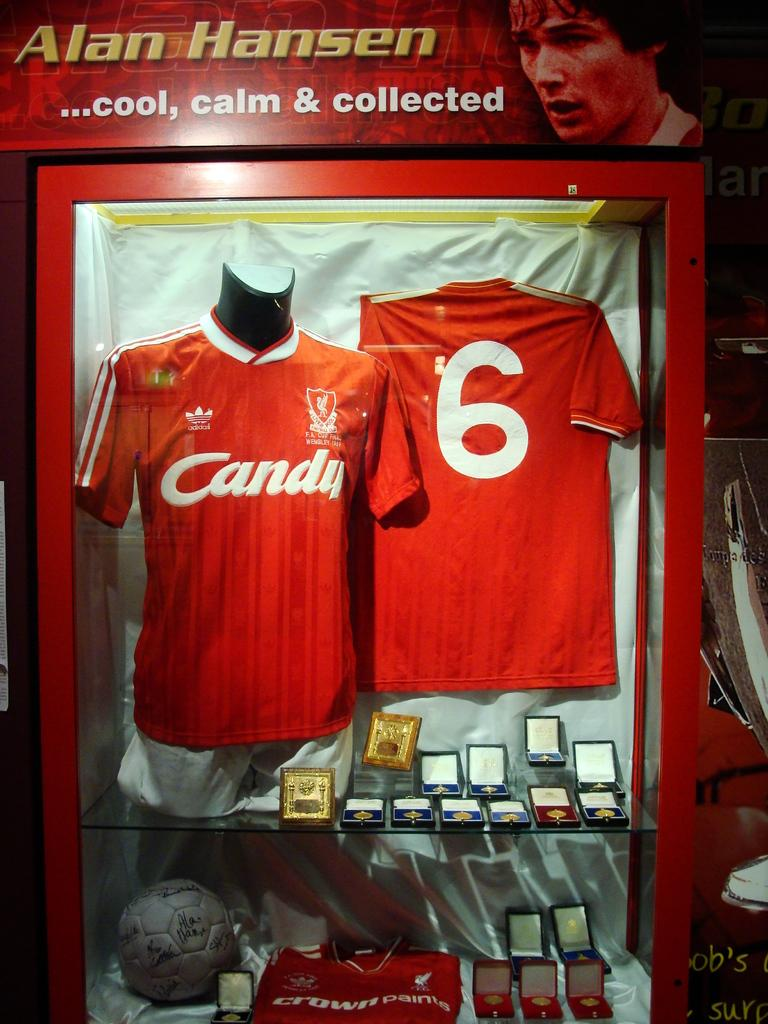<image>
Create a compact narrative representing the image presented. a red jersy in a frame with Candy on the front 